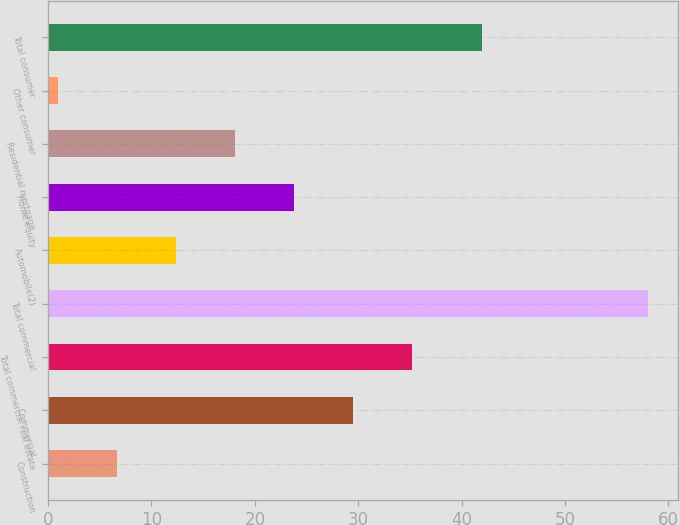Convert chart. <chart><loc_0><loc_0><loc_500><loc_500><bar_chart><fcel>Construction<fcel>Commercial<fcel>Total commercial real estate<fcel>Total commercial<fcel>Automobile(2)<fcel>Home equity<fcel>Residential mortgage<fcel>Other consumer<fcel>Total consumer<nl><fcel>6.7<fcel>29.5<fcel>35.2<fcel>58<fcel>12.4<fcel>23.8<fcel>18.1<fcel>1<fcel>42<nl></chart> 